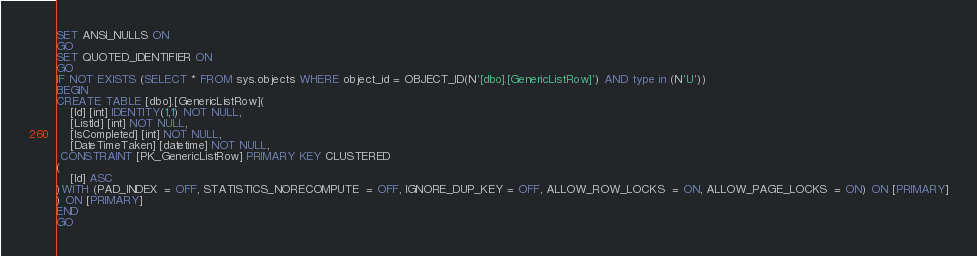Convert code to text. <code><loc_0><loc_0><loc_500><loc_500><_SQL_>SET ANSI_NULLS ON
GO
SET QUOTED_IDENTIFIER ON
GO
IF NOT EXISTS (SELECT * FROM sys.objects WHERE object_id = OBJECT_ID(N'[dbo].[GenericListRow]') AND type in (N'U'))
BEGIN
CREATE TABLE [dbo].[GenericListRow](
	[Id] [int] IDENTITY(1,1) NOT NULL,
	[ListId] [int] NOT NULL,
	[IsCompleted] [int] NOT NULL,
	[DateTimeTaken] [datetime] NOT NULL,
 CONSTRAINT [PK_GenericListRow] PRIMARY KEY CLUSTERED 
(
	[Id] ASC
)WITH (PAD_INDEX  = OFF, STATISTICS_NORECOMPUTE  = OFF, IGNORE_DUP_KEY = OFF, ALLOW_ROW_LOCKS  = ON, ALLOW_PAGE_LOCKS  = ON) ON [PRIMARY]
) ON [PRIMARY]
END
GO
</code> 